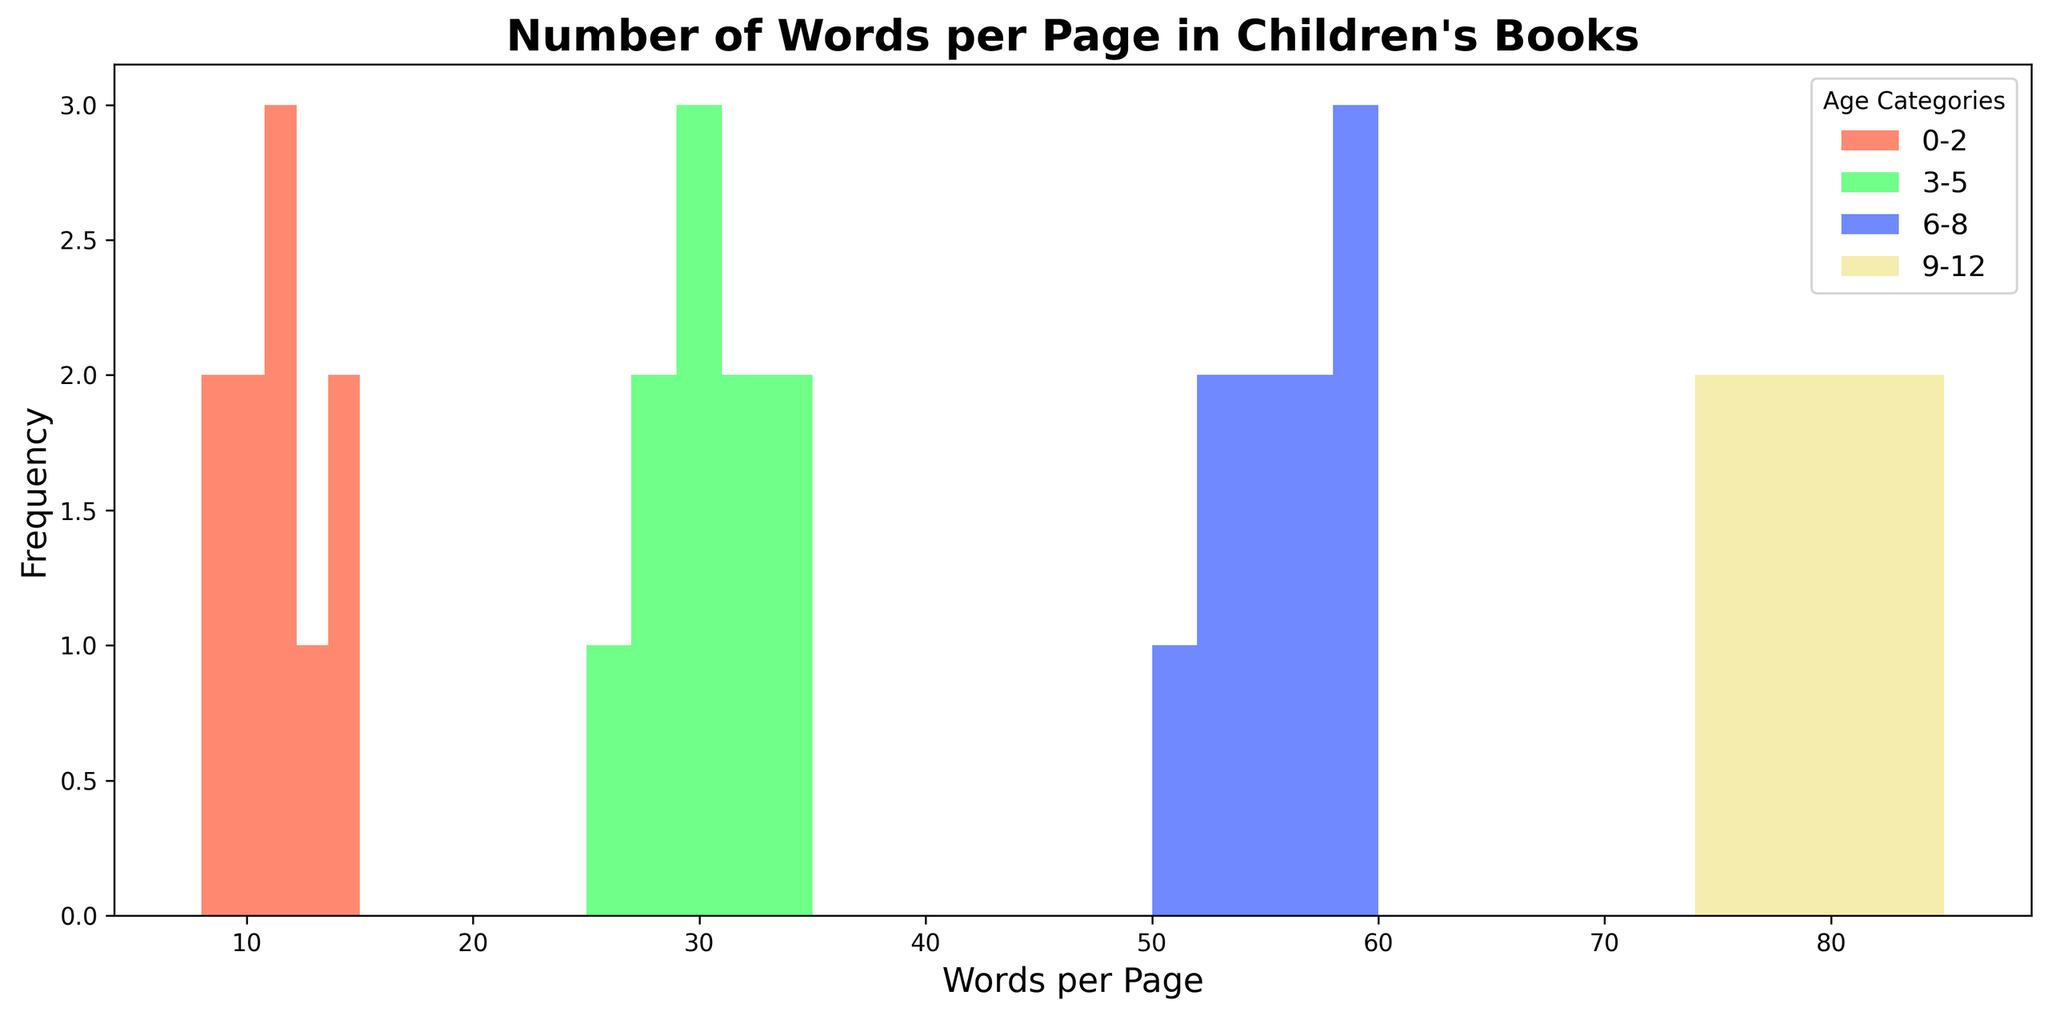What is the most frequent number of words per page for the 0-2 age category? To determine the most frequent number of words per page for the 0-2 age category, locate the bin with the highest bar in the histogram for that category (usually represented in a distinct color).
Answer: 10 or 12 Which age category has the highest variation in the number of words per page? To identify the highest variation, visually compare the range (difference between the longest bar and the shortest bar) of words per page across different age categories. The 9-12 category has the widest spread of data points.
Answer: 9-12 Which age category exhibits the least variation in the number of words per page? Similar to identifying the highest variation, find the category with the smallest range of words per page. The 6-8 category shows tightly grouped bars.
Answer: 6-8 Which age category has the highest number of words per page? Locate the maximum bin range in the histogram and identify the corresponding age category. The 9-12 age category has the highest number of words per page.
Answer: 9-12 What is the range of words per page for the 3-5 age category? To find the range of words per page for the 3-5 age category, identify the minimum and maximum values on the x-axis within that category’s color and take the difference. The word counts range from 25 to 35.
Answer: 10 Which age category has the most consistent word count per page? Consistency can be observed by the narrowness of the range and equal height of the bars. The 6-8 age category has a narrow distribution and similarly sized bars, indicating consistency.
Answer: 6-8 Is there any overlap in the ranges of words per page between the 0-2 and 3-5 age categories? Compare the x-axis ranges of both age categories. There is no overlap since the ranges for 0-2 and 3-5 categories are distinct.
Answer: No How does the frequency of the highest bar in the 0-2 age category compare to the highest bar in the 6-8 age category? Compare the height of the tallest bars in both categories to see which one is higher. The highest bar in the 6-8 category is taller than the highest bar in the 0-2 category.
Answer: Taller 